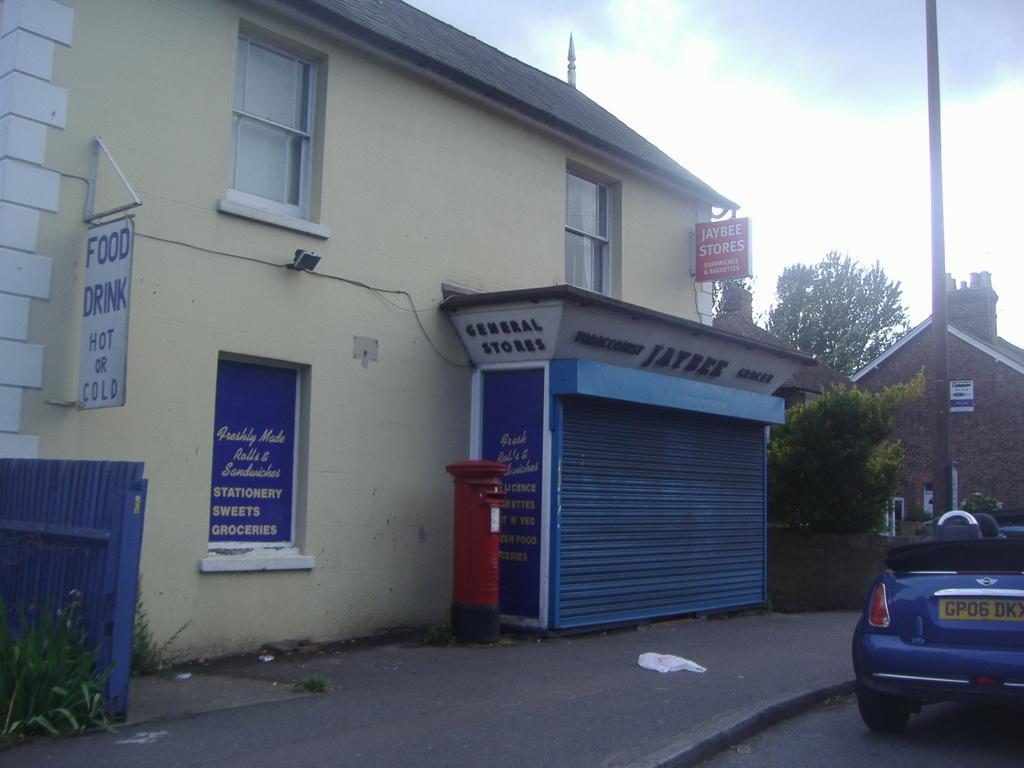Can you describe this image briefly? In this picture we can see a car on the road. This is the house and there is pole. These are the trees. Here we can see some boards. And this is the sky. 